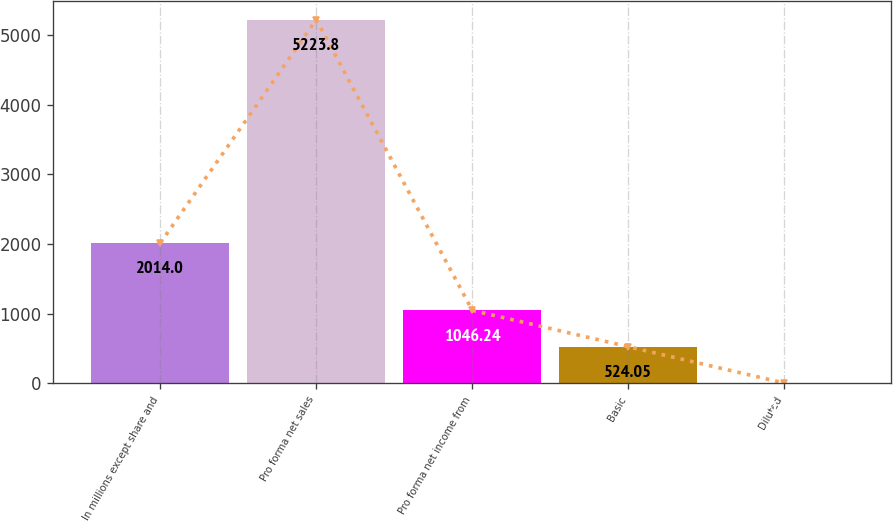<chart> <loc_0><loc_0><loc_500><loc_500><bar_chart><fcel>In millions except share and<fcel>Pro forma net sales<fcel>Pro forma net income from<fcel>Basic<fcel>Diluted<nl><fcel>2014<fcel>5223.8<fcel>1046.24<fcel>524.05<fcel>1.85<nl></chart> 